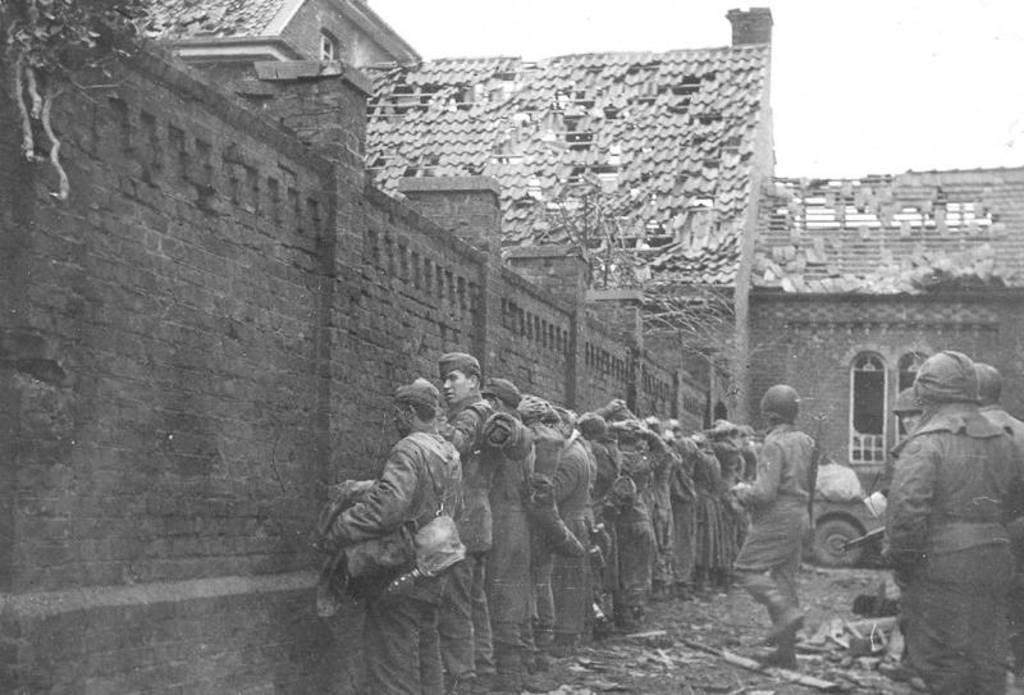How many people are in the image? There is a group of men in the image. What are the men doing in the image? The men are standing near a wall. What structure is located in the middle of the image? There appears to be a house in the middle of the image. Where is the map located in the image? There is no map present in the image. How many trucks are visible in the image? There are no trucks visible in the image. 